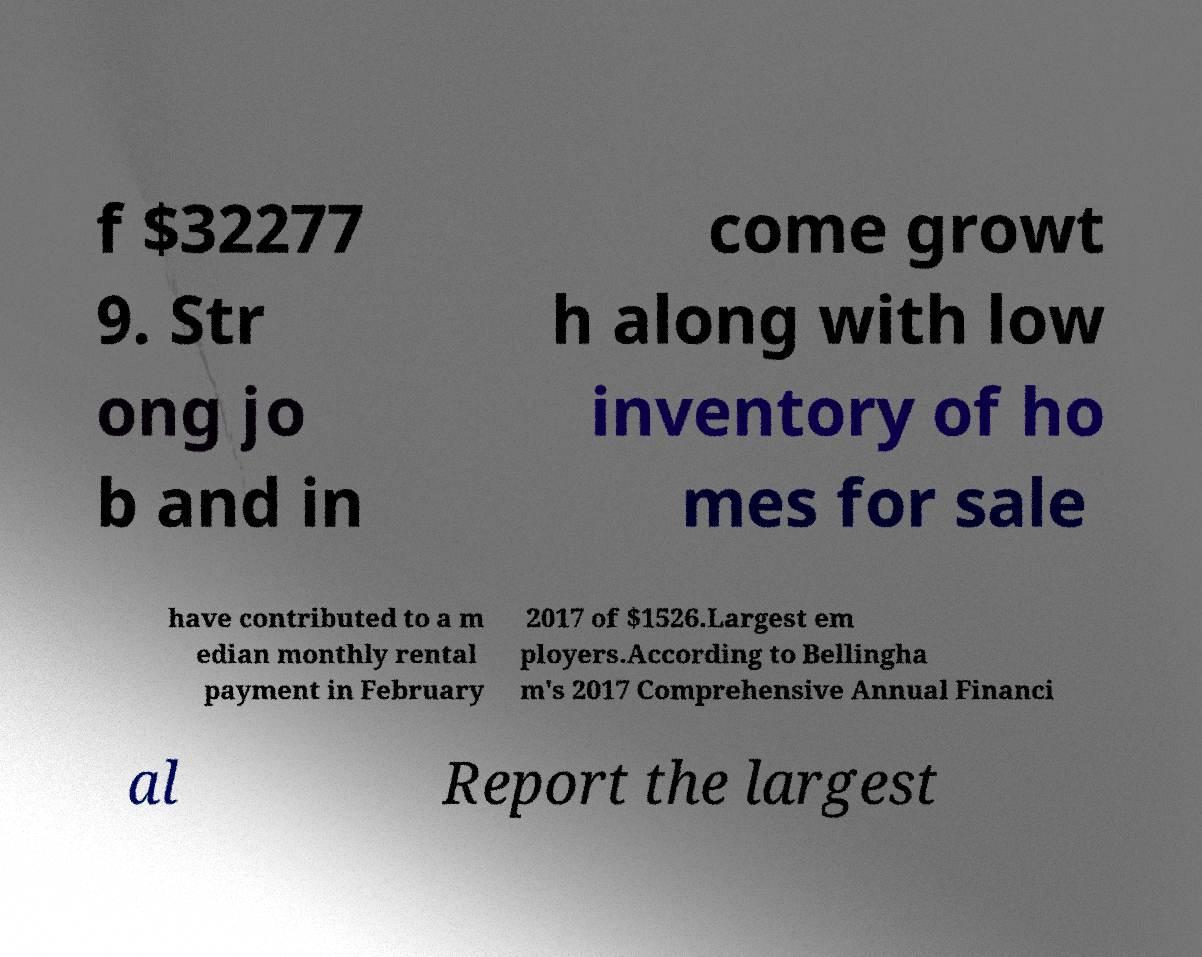Can you read and provide the text displayed in the image?This photo seems to have some interesting text. Can you extract and type it out for me? f $32277 9. Str ong jo b and in come growt h along with low inventory of ho mes for sale have contributed to a m edian monthly rental payment in February 2017 of $1526.Largest em ployers.According to Bellingha m's 2017 Comprehensive Annual Financi al Report the largest 